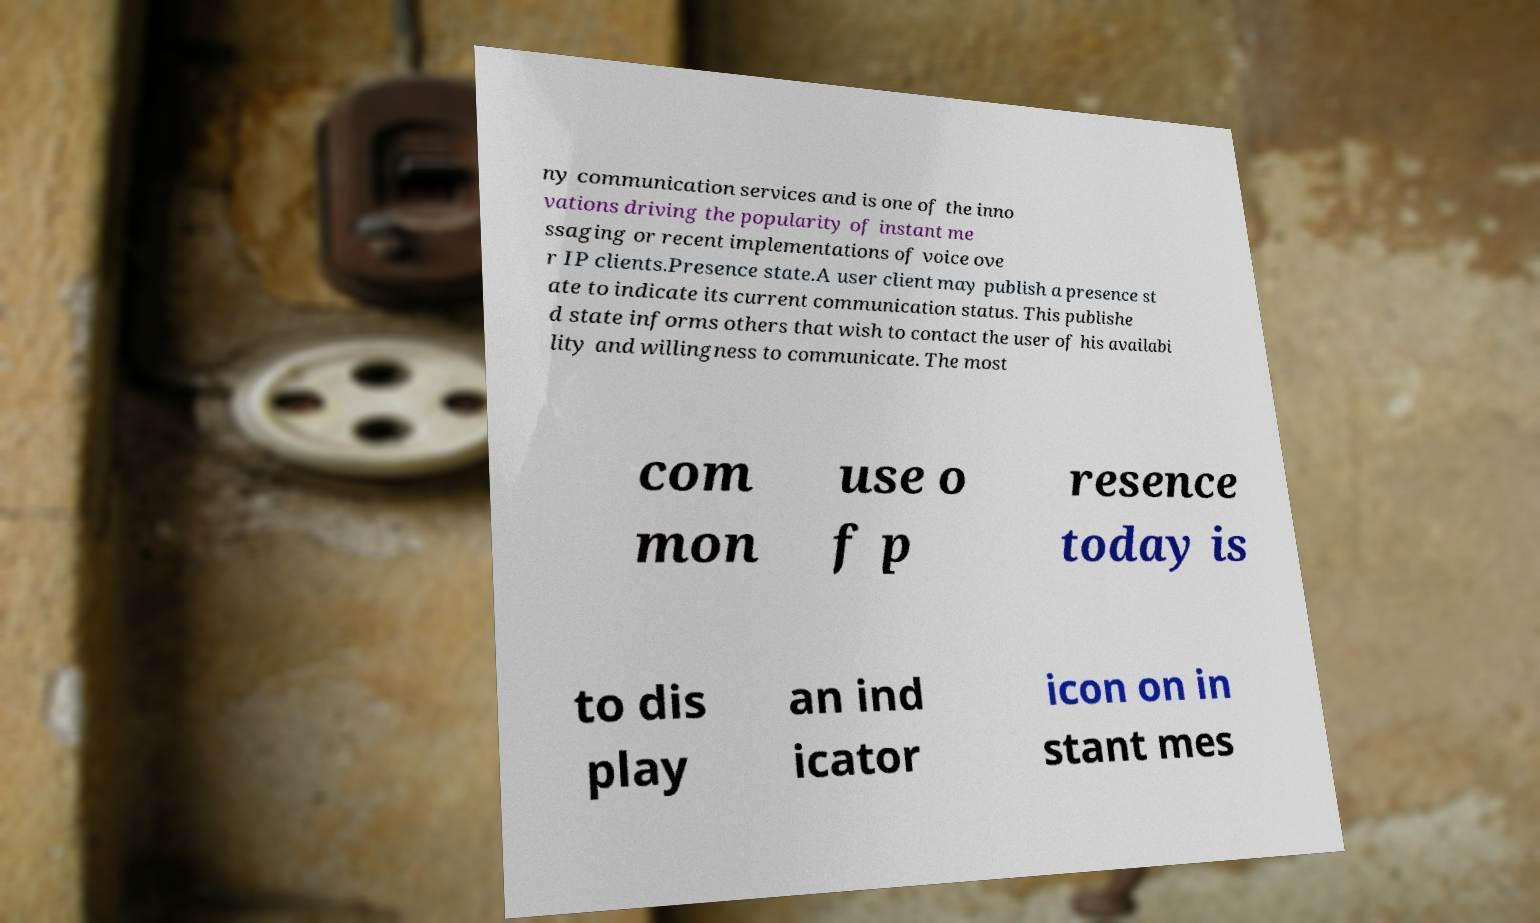Could you extract and type out the text from this image? ny communication services and is one of the inno vations driving the popularity of instant me ssaging or recent implementations of voice ove r IP clients.Presence state.A user client may publish a presence st ate to indicate its current communication status. This publishe d state informs others that wish to contact the user of his availabi lity and willingness to communicate. The most com mon use o f p resence today is to dis play an ind icator icon on in stant mes 